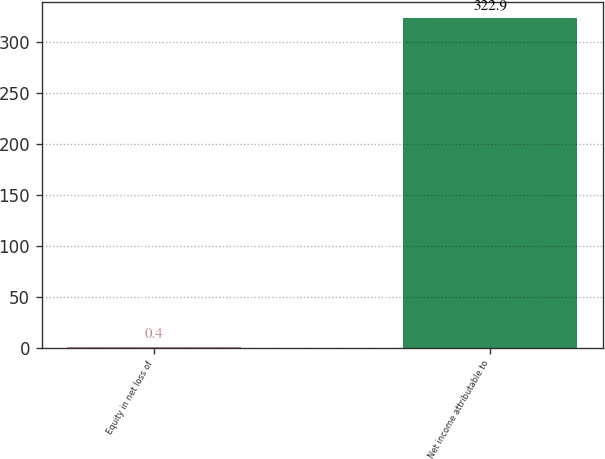<chart> <loc_0><loc_0><loc_500><loc_500><bar_chart><fcel>Equity in net loss of<fcel>Net income attributable to<nl><fcel>0.4<fcel>322.9<nl></chart> 